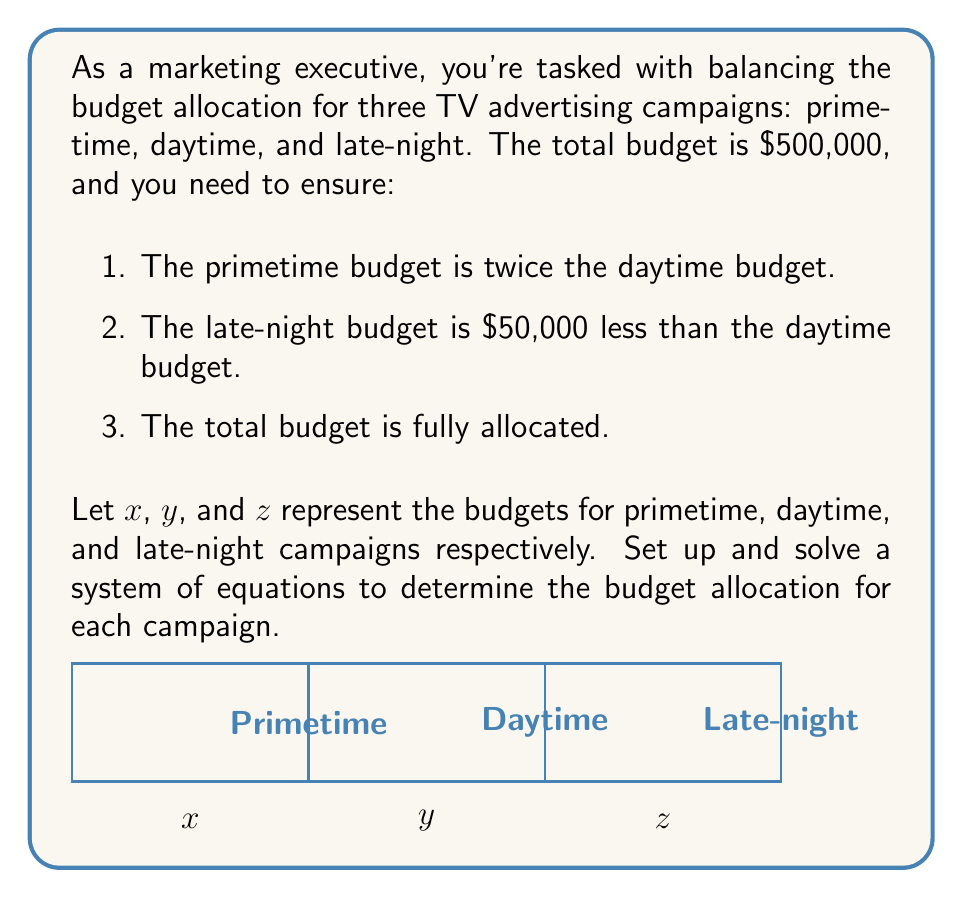Can you solve this math problem? Let's approach this step-by-step:

1) First, let's set up our system of equations based on the given conditions:

   $$\begin{cases}
   x = 2y & \text{(primetime is twice daytime)}\\
   z = y - 50000 & \text{(late-night is $50,000 less than daytime)}\\
   x + y + z = 500000 & \text{(total budget)}
   \end{cases}$$

2) We can substitute the first two equations into the third:

   $$2y + y + (y - 50000) = 500000$$

3) Simplify:

   $$4y - 50000 = 500000$$

4) Solve for $y$:

   $$4y = 550000$$
   $$y = 137500$$

5) Now that we know $y$, we can find $x$ and $z$:

   $$x = 2y = 2(137500) = 275000$$
   $$z = y - 50000 = 137500 - 50000 = 87500$$

6) Let's verify that these values satisfy our conditions:
   - Primetime ($275000) is twice daytime ($137500)
   - Late-night ($87500) is $50,000 less than daytime ($137500)
   - Total: $275000 + 137500 + 87500 = 500000$

Therefore, the budget allocations are:
Primetime: $275,000
Daytime: $137,500
Late-night: $87,500
Answer: Primetime: $275,000, Daytime: $137,500, Late-night: $87,500 